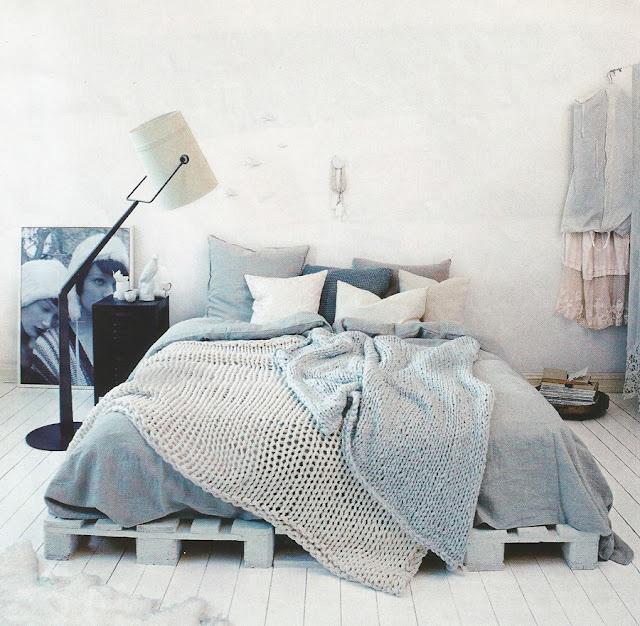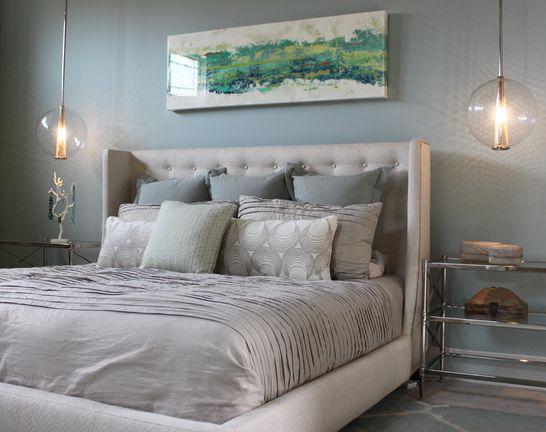The first image is the image on the left, the second image is the image on the right. For the images shown, is this caption "At least one of the beds has a grey headboard." true? Answer yes or no. Yes. 